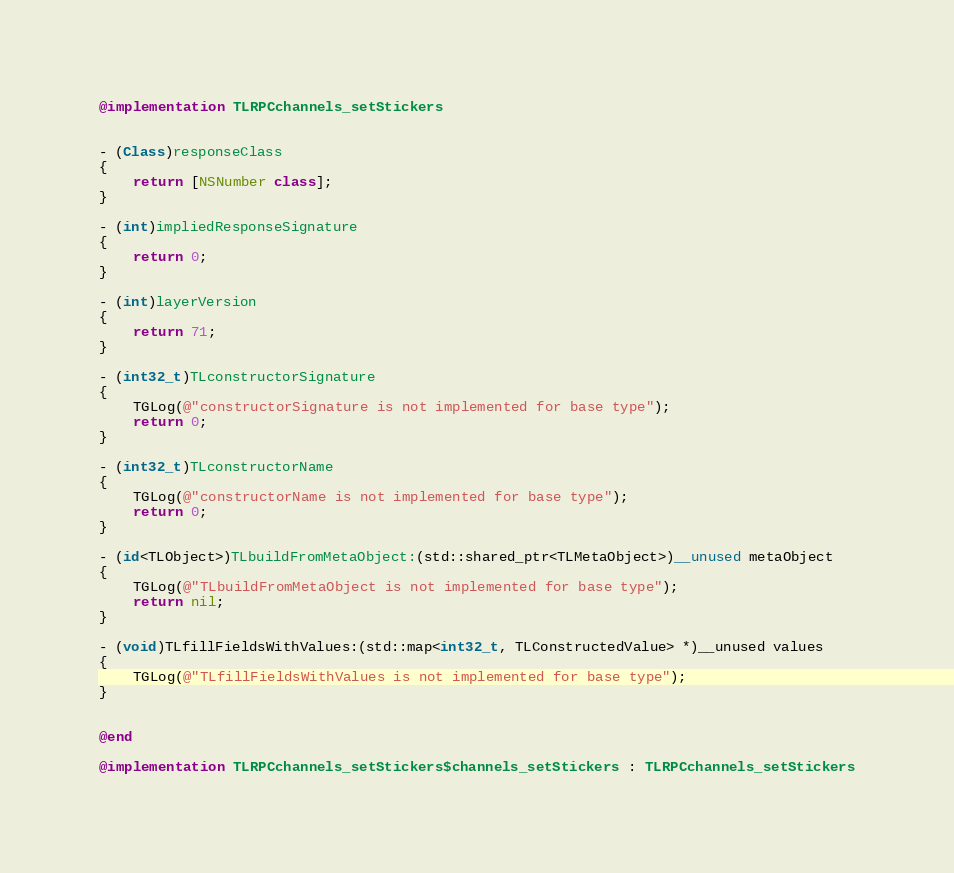<code> <loc_0><loc_0><loc_500><loc_500><_ObjectiveC_>@implementation TLRPCchannels_setStickers


- (Class)responseClass
{
    return [NSNumber class];
}

- (int)impliedResponseSignature
{
    return 0;
}

- (int)layerVersion
{
    return 71;
}

- (int32_t)TLconstructorSignature
{
    TGLog(@"constructorSignature is not implemented for base type");
    return 0;
}

- (int32_t)TLconstructorName
{
    TGLog(@"constructorName is not implemented for base type");
    return 0;
}

- (id<TLObject>)TLbuildFromMetaObject:(std::shared_ptr<TLMetaObject>)__unused metaObject
{
    TGLog(@"TLbuildFromMetaObject is not implemented for base type");
    return nil;
}

- (void)TLfillFieldsWithValues:(std::map<int32_t, TLConstructedValue> *)__unused values
{
    TGLog(@"TLfillFieldsWithValues is not implemented for base type");
}


@end

@implementation TLRPCchannels_setStickers$channels_setStickers : TLRPCchannels_setStickers

</code> 